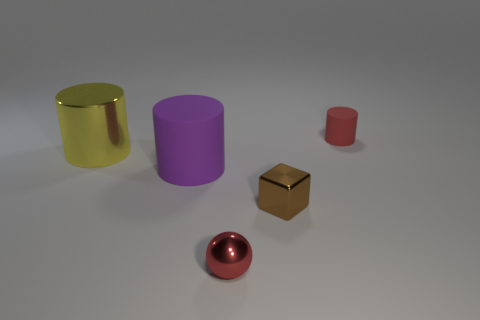How many metal things are to the right of the tiny sphere and behind the big matte thing?
Your answer should be compact. 0. How big is the red object that is to the left of the rubber cylinder that is on the right side of the large purple cylinder?
Offer a terse response. Small. Is the number of large purple matte things greater than the number of green metal objects?
Provide a succinct answer. Yes. Is the color of the small metal object that is in front of the small brown thing the same as the matte thing that is to the right of the purple rubber thing?
Your answer should be very brief. Yes. Is there a small red metallic thing that is left of the metallic object that is right of the tiny red shiny thing?
Provide a succinct answer. Yes. Are there fewer small red metal things behind the red cylinder than yellow shiny cylinders that are to the left of the small brown metal thing?
Your answer should be compact. Yes. Is the large cylinder left of the purple cylinder made of the same material as the red object in front of the large purple rubber thing?
Your answer should be very brief. Yes. What number of large objects are metallic cylinders or green cubes?
Offer a terse response. 1. There is a small red thing that is made of the same material as the yellow thing; what shape is it?
Make the answer very short. Sphere. Are there fewer tiny red balls that are behind the brown object than cyan blocks?
Keep it short and to the point. No. 